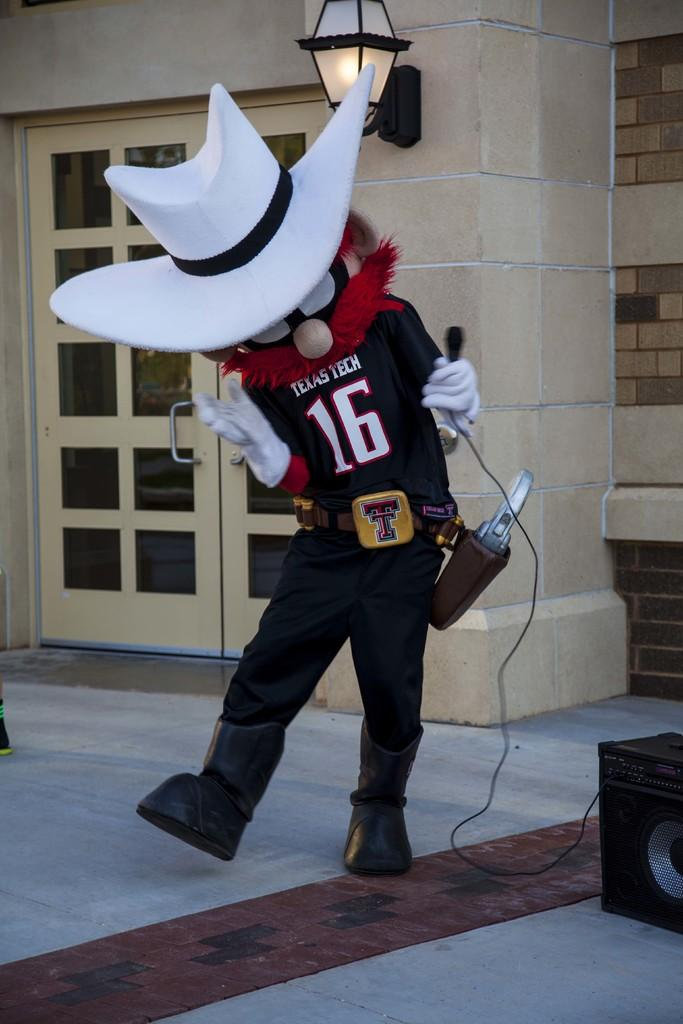What is the person in the image holding? The person is holding a mic. Can you describe the person's attire? The person is wearing a hat. What can be seen in the background of the image? There is a door in the background. Are there any light sources in the image? Yes, there is a lamp on the wall. What other equipment is visible in the image? A speaker is visible in the image. Who is the creator of the chess game being played in the image? There is no chess game present in the image, so it is not possible to determine who the creator might be. 